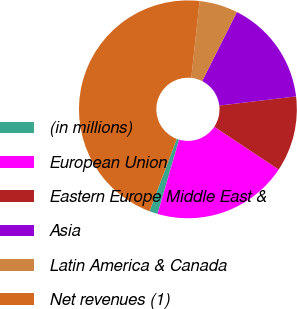<chart> <loc_0><loc_0><loc_500><loc_500><pie_chart><fcel>(in millions)<fcel>European Union<fcel>Eastern Europe Middle East &<fcel>Asia<fcel>Latin America & Canada<fcel>Net revenues (1)<nl><fcel>1.24%<fcel>20.17%<fcel>11.22%<fcel>15.69%<fcel>5.71%<fcel>45.98%<nl></chart> 